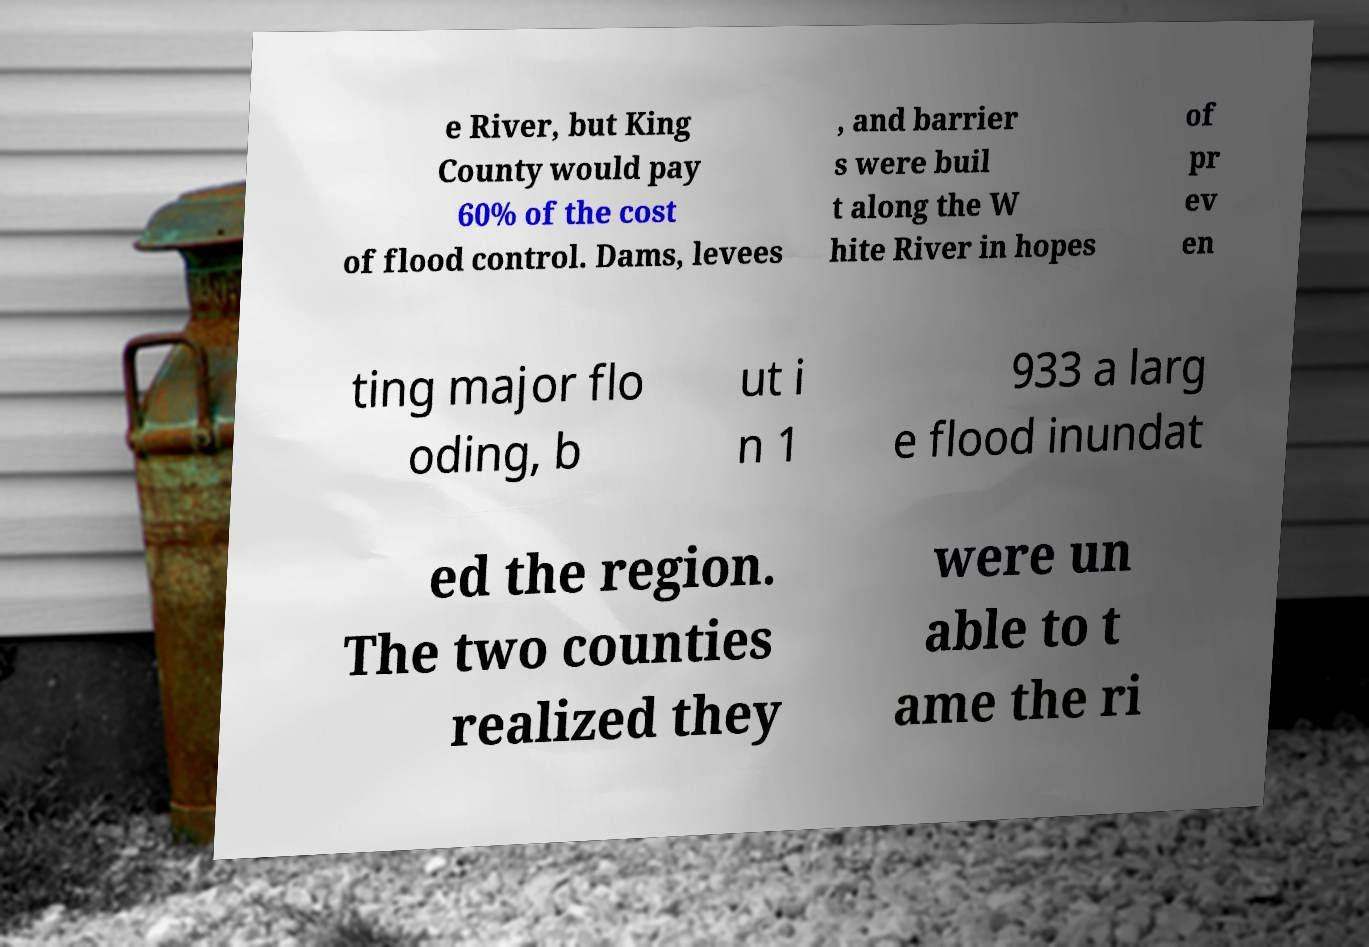Can you read and provide the text displayed in the image?This photo seems to have some interesting text. Can you extract and type it out for me? e River, but King County would pay 60% of the cost of flood control. Dams, levees , and barrier s were buil t along the W hite River in hopes of pr ev en ting major flo oding, b ut i n 1 933 a larg e flood inundat ed the region. The two counties realized they were un able to t ame the ri 